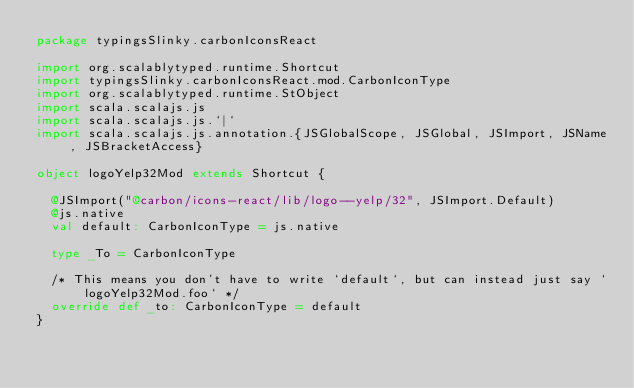Convert code to text. <code><loc_0><loc_0><loc_500><loc_500><_Scala_>package typingsSlinky.carbonIconsReact

import org.scalablytyped.runtime.Shortcut
import typingsSlinky.carbonIconsReact.mod.CarbonIconType
import org.scalablytyped.runtime.StObject
import scala.scalajs.js
import scala.scalajs.js.`|`
import scala.scalajs.js.annotation.{JSGlobalScope, JSGlobal, JSImport, JSName, JSBracketAccess}

object logoYelp32Mod extends Shortcut {
  
  @JSImport("@carbon/icons-react/lib/logo--yelp/32", JSImport.Default)
  @js.native
  val default: CarbonIconType = js.native
  
  type _To = CarbonIconType
  
  /* This means you don't have to write `default`, but can instead just say `logoYelp32Mod.foo` */
  override def _to: CarbonIconType = default
}
</code> 